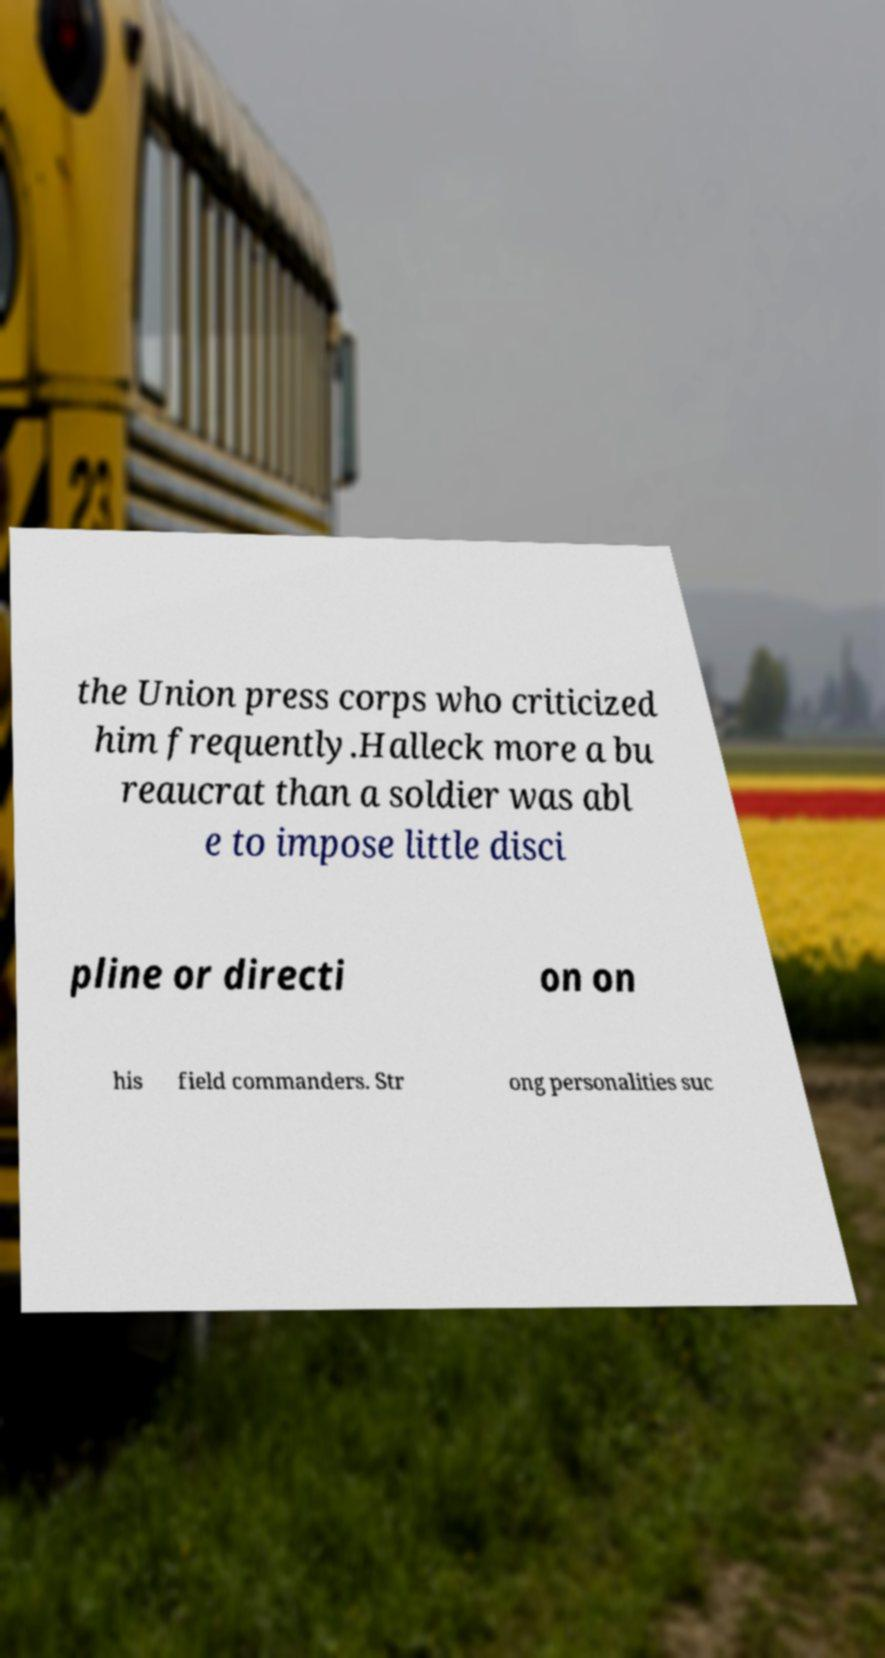Could you extract and type out the text from this image? the Union press corps who criticized him frequently.Halleck more a bu reaucrat than a soldier was abl e to impose little disci pline or directi on on his field commanders. Str ong personalities suc 